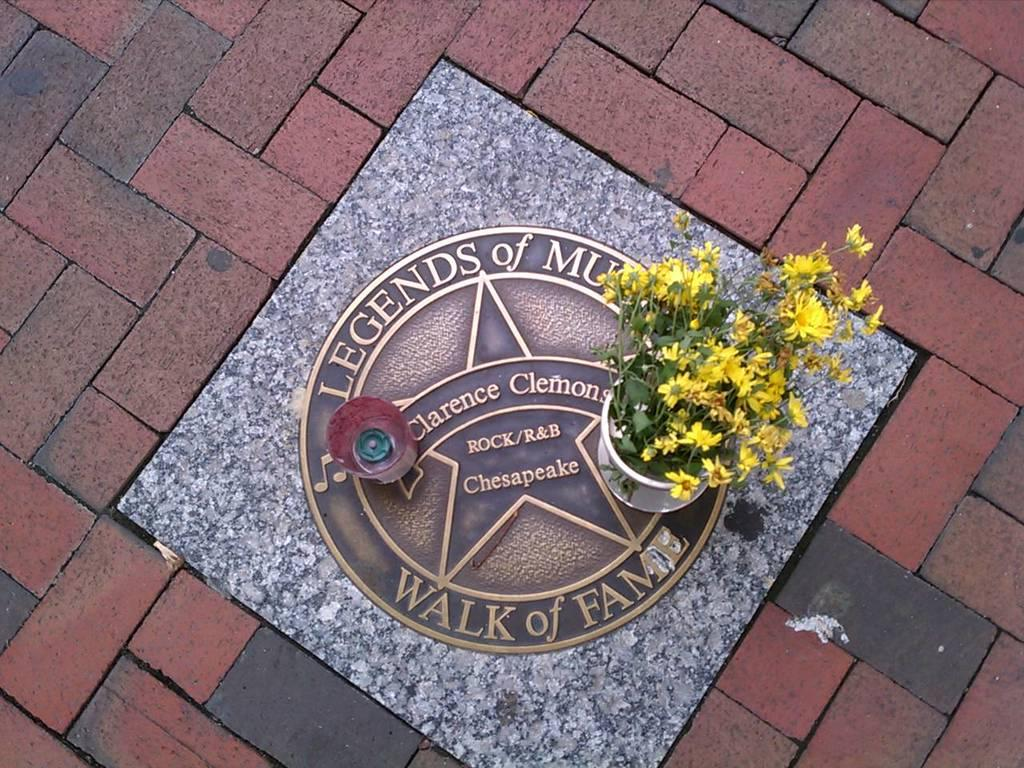What type of plant is in the pot in the image? There is a plant with flowers in a pot in the image. Where is the pot placed? The pot is placed on a marble surface. What is on the marble surface besides the pot? The marble surface has a symbol with some text on it. What is located beside the pot? There is a container beside the pot. What is the weather like in the image? The provided facts do not mention any information about the weather, so it cannot be determined from the image. 